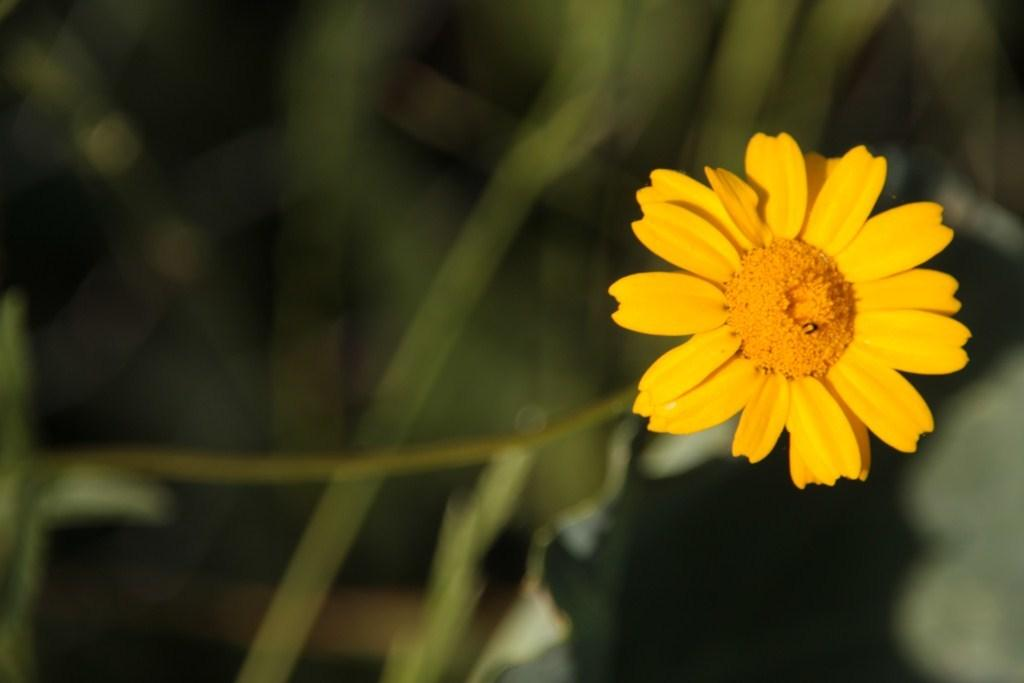What is the main subject in the foreground of the image? There is a yellow flower in the foreground of the image. On which side of the image is the flower located? The flower is on the right side of the image. Can you describe the background of the image? The background of the image is blurred. How many mice are hiding behind the yellow flower in the image? There are no mice present in the image; it only features a yellow flower. What type of magic is being performed by the flower in the image? There is no magic being performed by the flower in the image; it is a static image of a yellow flower. 